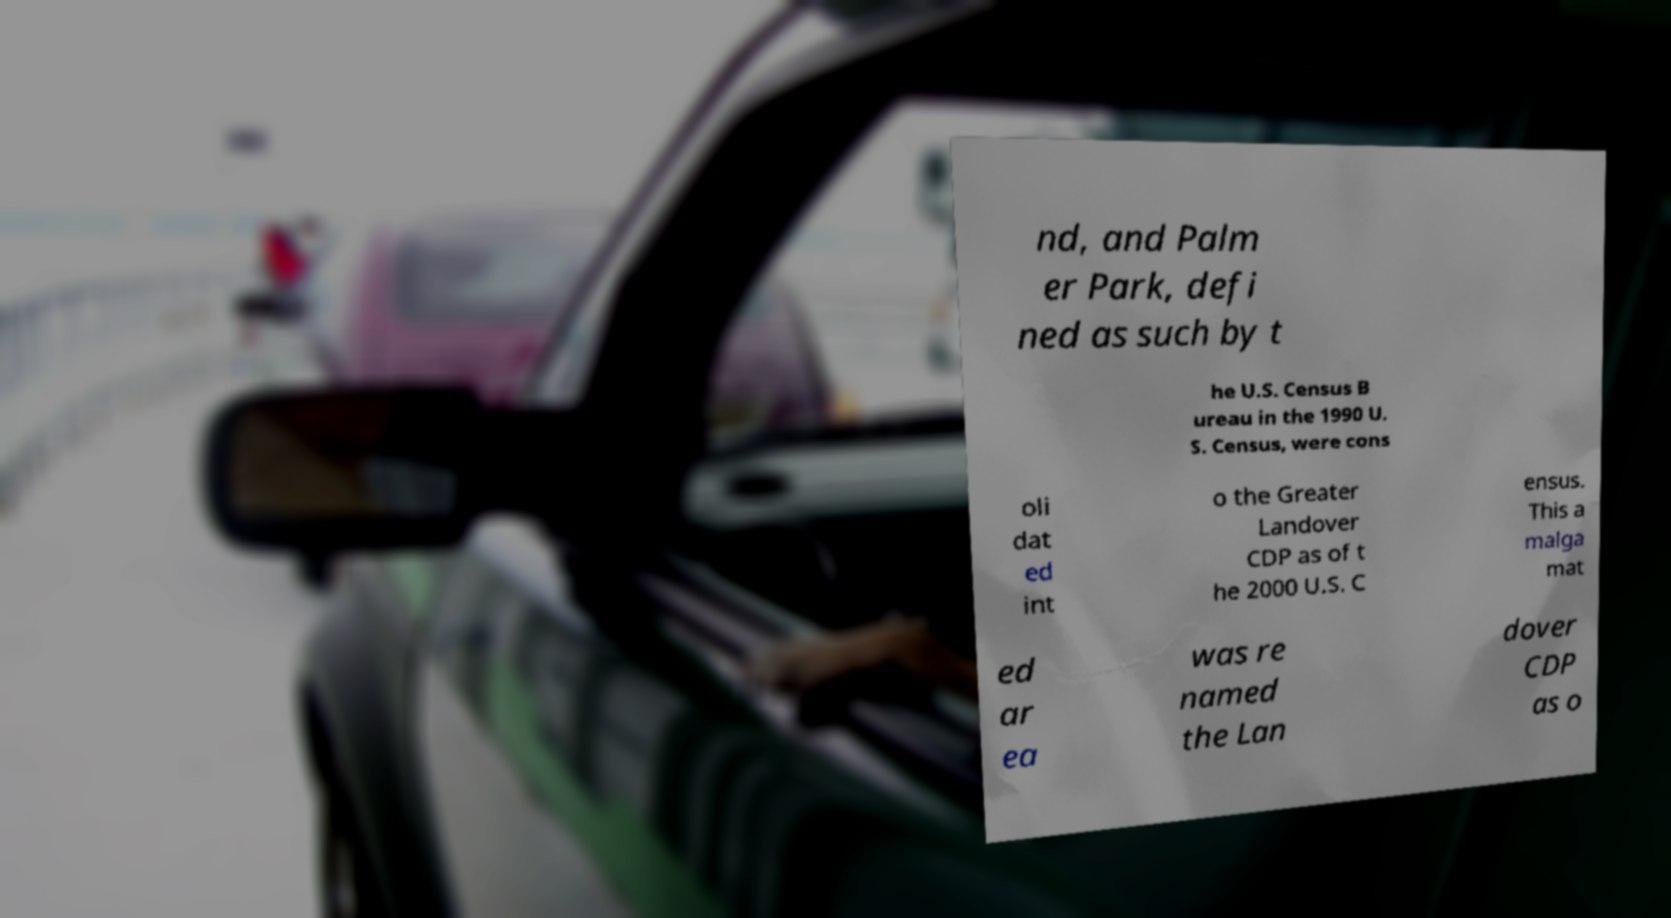There's text embedded in this image that I need extracted. Can you transcribe it verbatim? nd, and Palm er Park, defi ned as such by t he U.S. Census B ureau in the 1990 U. S. Census, were cons oli dat ed int o the Greater Landover CDP as of t he 2000 U.S. C ensus. This a malga mat ed ar ea was re named the Lan dover CDP as o 